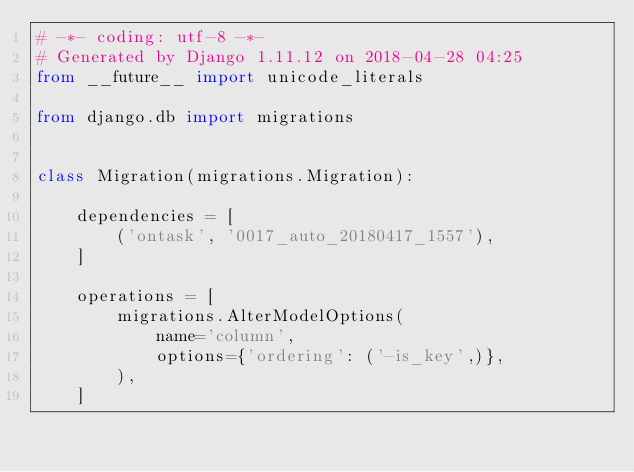Convert code to text. <code><loc_0><loc_0><loc_500><loc_500><_Python_># -*- coding: utf-8 -*-
# Generated by Django 1.11.12 on 2018-04-28 04:25
from __future__ import unicode_literals

from django.db import migrations


class Migration(migrations.Migration):

    dependencies = [
        ('ontask', '0017_auto_20180417_1557'),
    ]

    operations = [
        migrations.AlterModelOptions(
            name='column',
            options={'ordering': ('-is_key',)},
        ),
    ]
</code> 